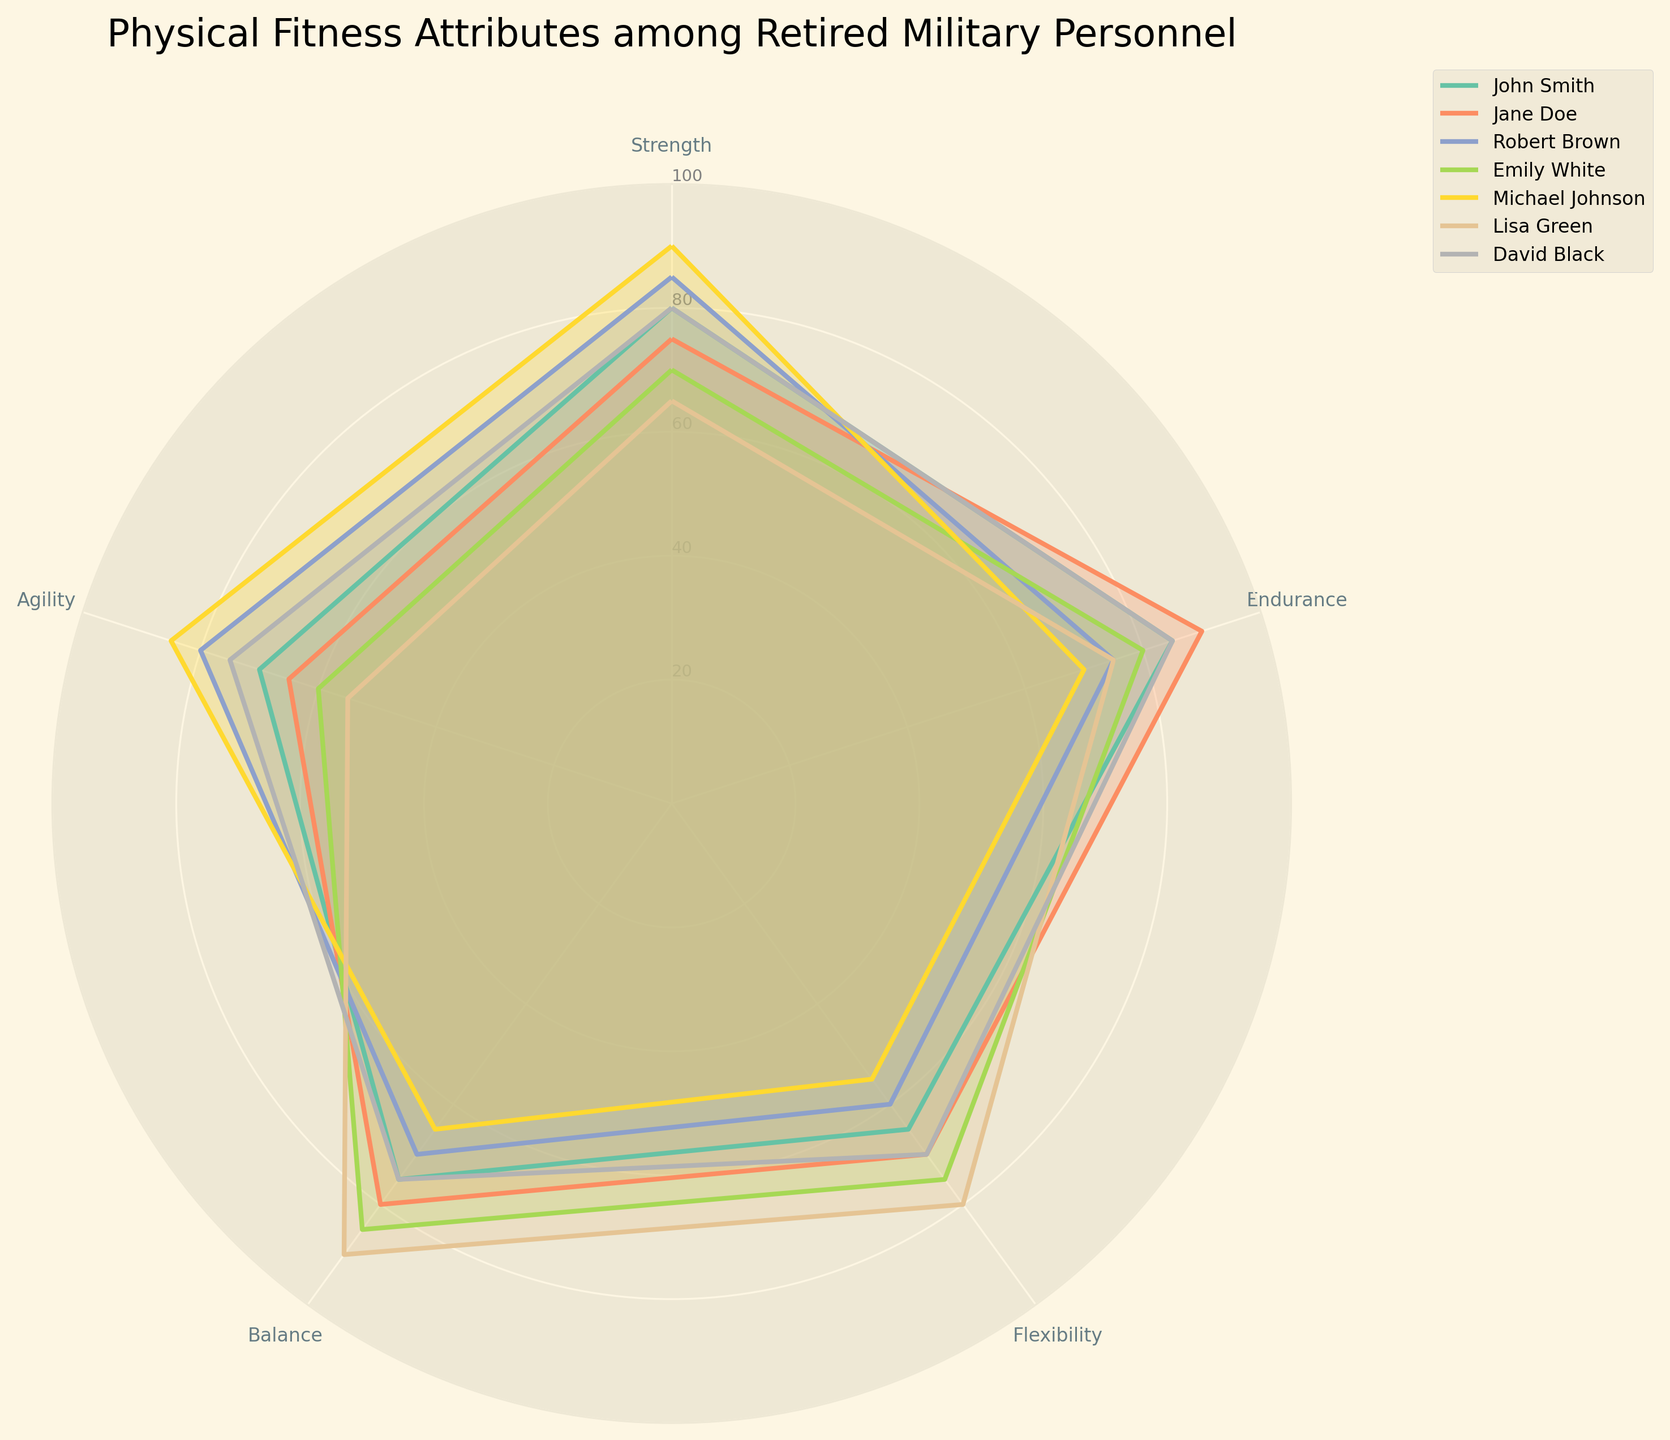what is the title of the figure? The title of the figure is located at the top, and it reads "Physical Fitness Attributes among Retired Military Personnel"
Answer: Physical Fitness Attributes among Retired Military Personnel How many categories are evaluated in the chart? The categories can be seen along the axes, and there are five labeled: Strength, Endurance, Flexibility, Balance, Agility
Answer: 5 Which individual has the highest score in balance? To answer this, find the highest value under the Balance category. Emily White has the highest score of 85
Answer: Emily White Who has the lowest score in agility? Check the agility scores for all individuals and find the lowest one. Lisa Green has the lowest score of 55
Answer: Lisa Green What is the difference in strength between John Smith and Emily White? John Smith has a strength score of 80, and Emily White has a strength score of 70. Subtract Emily White's score from John Smith's: 80 - 70 = 10
Answer: 10 How does Michael Johnson's endurance compare to Jane Doe's endurance? Michael Johnson has an endurance score of 70 while Jane Doe has 90, so Michael Johnson's endurance is 20 points lower
Answer: 20 points lower Which individual has the most balanced scores across all categories? To answer this, examine which individual has the least fluctuation in scores across the categories. This involves comparing how close each score is to the others. Emily White has scores of Strength: 70, Endurance: 80, Flexibility: 75, Balance: 85, Agility: 60, showing the least variation
Answer: Emily White What is the median agility score for the group? List the agility scores (70, 65, 80, 60, 85, 55, 75) and find the median. After sorting (55, 60, 65, 70, 75, 80, 85), the middle value is 70
Answer: 70 